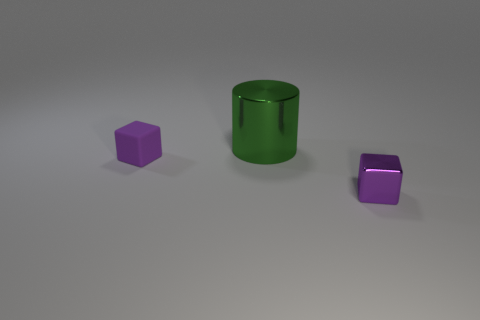Describe the surface the objects are resting on. The objects are resting on a flat, matte surface that has a very subtle gradient, possibly hinting at a slight curvature or a lighting effect.  How many different colors are present among the objects? In the image, there are two distinct colors present among the objects: green for the cylinder and purple for both cubes. 